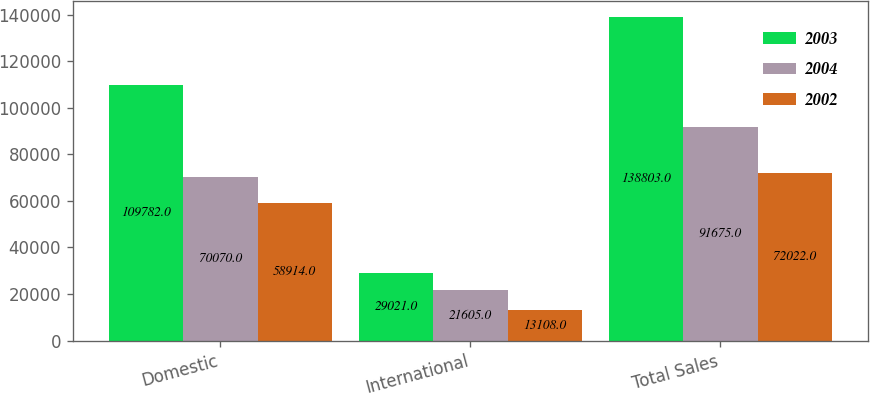<chart> <loc_0><loc_0><loc_500><loc_500><stacked_bar_chart><ecel><fcel>Domestic<fcel>International<fcel>Total Sales<nl><fcel>2003<fcel>109782<fcel>29021<fcel>138803<nl><fcel>2004<fcel>70070<fcel>21605<fcel>91675<nl><fcel>2002<fcel>58914<fcel>13108<fcel>72022<nl></chart> 